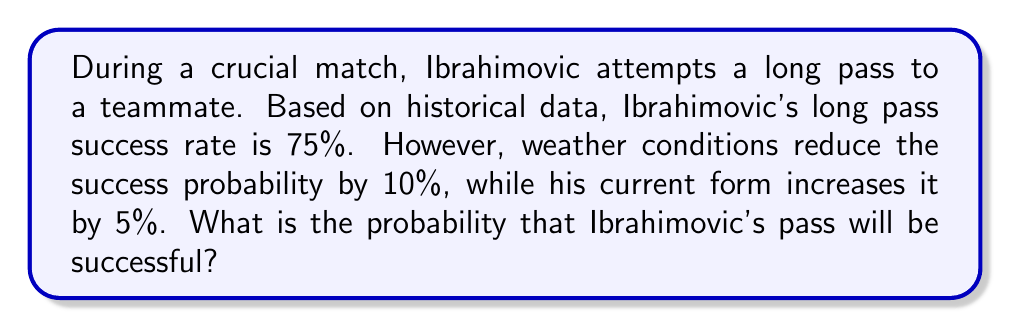Show me your answer to this math problem. Let's approach this step-by-step:

1) First, we start with Ibrahimovic's base success rate for long passes:
   $p_{base} = 0.75$ or 75%

2) The weather conditions reduce the probability by 10%:
   $p_{weather} = 0.75 - (0.75 \times 0.10) = 0.75 - 0.075 = 0.675$ or 67.5%

3) His current form increases the probability by 5%:
   $p_{final} = 0.675 + (0.675 \times 0.05) = 0.675 + 0.03375 = 0.70875$

4) To convert to a percentage, we multiply by 100:
   $0.70875 \times 100 = 70.875\%$

Therefore, the probability of Ibrahimovic's pass being successful under these conditions is approximately 70.88%.
Answer: $70.88\%$ 